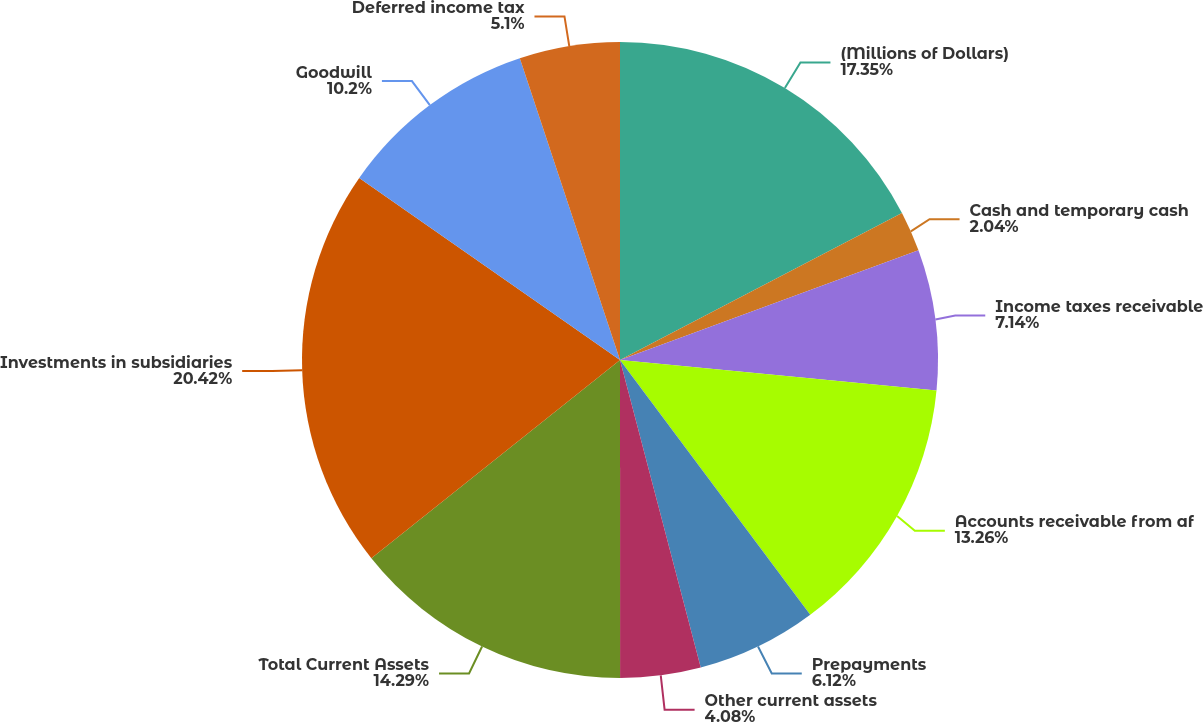Convert chart. <chart><loc_0><loc_0><loc_500><loc_500><pie_chart><fcel>(Millions of Dollars)<fcel>Cash and temporary cash<fcel>Income taxes receivable<fcel>Accounts receivable from af<fcel>Prepayments<fcel>Other current assets<fcel>Total Current Assets<fcel>Investments in subsidiaries<fcel>Goodwill<fcel>Deferred income tax<nl><fcel>17.35%<fcel>2.04%<fcel>7.14%<fcel>13.26%<fcel>6.12%<fcel>4.08%<fcel>14.29%<fcel>20.41%<fcel>10.2%<fcel>5.1%<nl></chart> 